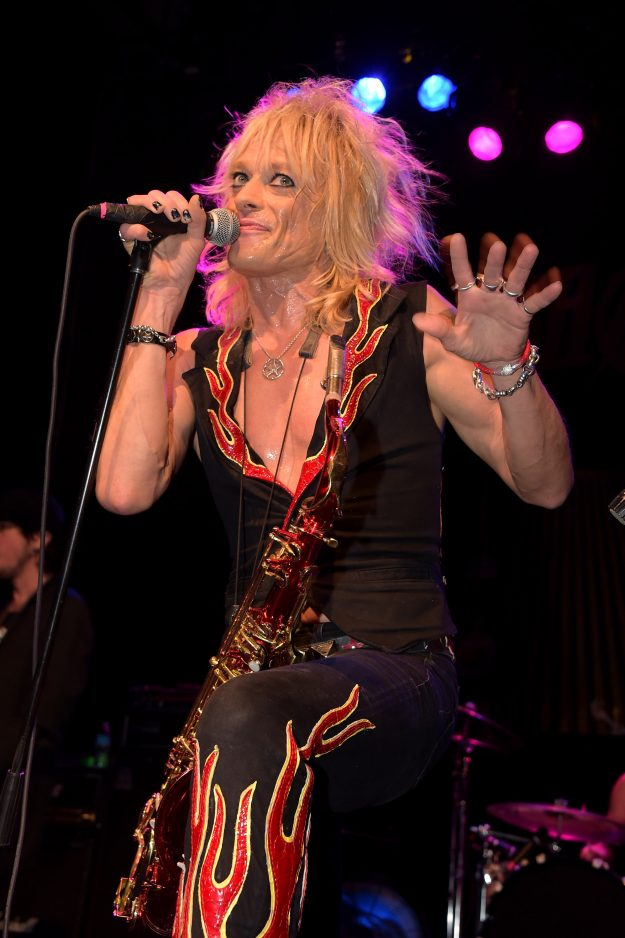Describe how the performer's outfit choices contribute to the overall atmosphere of the concert. The performer's outfit, featuring a black sleeveless top with red flame designs and matching pants, adds to the concert's high-energy and vibrant atmosphere. The bold flames on the outfit symbolize intensity and passion, which is echoed in the performer's dynamic stage presence. The choice of accessories, like the bracelets and necklace, further enhances this fiery aesthetic, creating a cohesive look that amplifies the sense of excitement and raw emotion often found in rock performances. This visual synergy between the performer’s attire and their musical genre helps to immerse the audience in the concert experience, making it more memorable and impactful. 